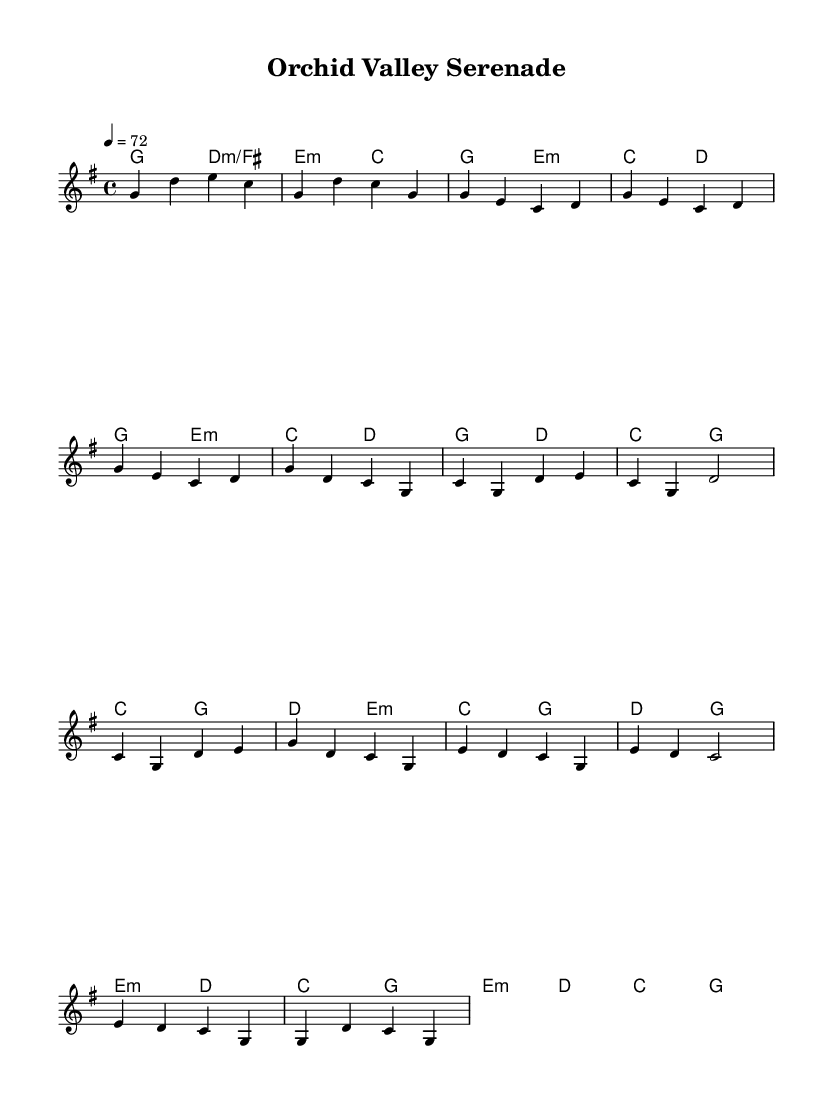What is the key signature of this music? The key signature is G major, which has one sharp (F#). This can be determined by looking at the key signature at the beginning of the staff, which indicates the notes affected by sharps or flats.
Answer: G major What is the time signature of this music? The time signature is 4/4, which means there are four beats in each measure and the quarter note receives one beat. This is indicated at the beginning of the sheet music, right after the key signature.
Answer: 4/4 What is the tempo marking for this music? The tempo marking is 72 beats per minute, as indicated in the score where it says "4 = 72" at the beginning. This indicates the speed at which the piece should be played.
Answer: 72 How many measures are in the melody part? The melody part contains 16 measures. By counting each segment divided by vertical lines, it's noted that there are 16 distinct measures in the melody section provided.
Answer: 16 What are the primary chords used in the chorus? The primary chords in the chorus are C, G, D, and E minor. In the chorus section of the sheet music, these chords appear consistently and can be identified in the harmony line accompanying the melody.
Answer: C, G, D, E minor What is the overall mood suggested by the title of the piece? The title "Orchid Valley Serenade" suggests a peaceful and calm mood, aligning with the theme of solitude and tranquility typically found in remote natural habitats. This can be inferred from the serene imagery presented in the title.
Answer: Peaceful What is the structure of the overall piece? The structure includes an intro, verse 1, chorus, and a bridge. This can be determined by analyzing the sections indicated in the sheet music, which clearly labels these parts sequentially.
Answer: Intro, Verse, Chorus, Bridge 